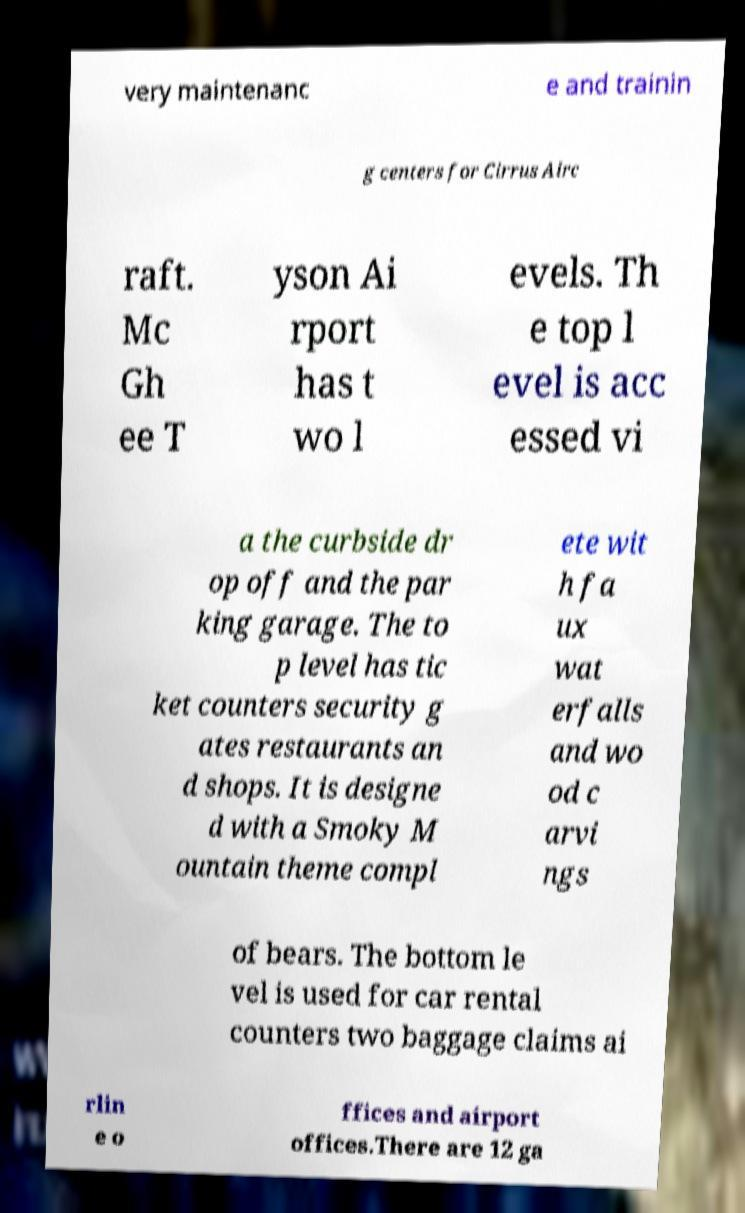For documentation purposes, I need the text within this image transcribed. Could you provide that? very maintenanc e and trainin g centers for Cirrus Airc raft. Mc Gh ee T yson Ai rport has t wo l evels. Th e top l evel is acc essed vi a the curbside dr op off and the par king garage. The to p level has tic ket counters security g ates restaurants an d shops. It is designe d with a Smoky M ountain theme compl ete wit h fa ux wat erfalls and wo od c arvi ngs of bears. The bottom le vel is used for car rental counters two baggage claims ai rlin e o ffices and airport offices.There are 12 ga 